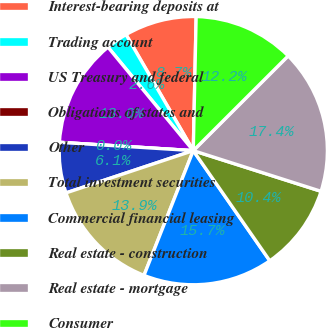Convert chart to OTSL. <chart><loc_0><loc_0><loc_500><loc_500><pie_chart><fcel>Interest-bearing deposits at<fcel>Trading account<fcel>US Treasury and federal<fcel>Obligations of states and<fcel>Other<fcel>Total investment securities<fcel>Commercial financial leasing<fcel>Real estate - construction<fcel>Real estate - mortgage<fcel>Consumer<nl><fcel>8.7%<fcel>2.61%<fcel>13.04%<fcel>0.0%<fcel>6.09%<fcel>13.91%<fcel>15.65%<fcel>10.43%<fcel>17.39%<fcel>12.17%<nl></chart> 